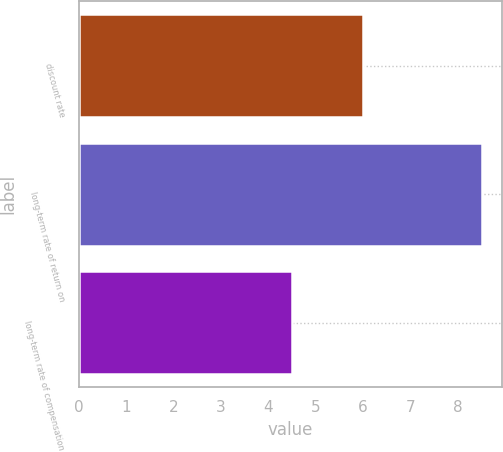Convert chart to OTSL. <chart><loc_0><loc_0><loc_500><loc_500><bar_chart><fcel>discount rate<fcel>long-term rate of return on<fcel>long-term rate of compensation<nl><fcel>6<fcel>8.5<fcel>4.5<nl></chart> 